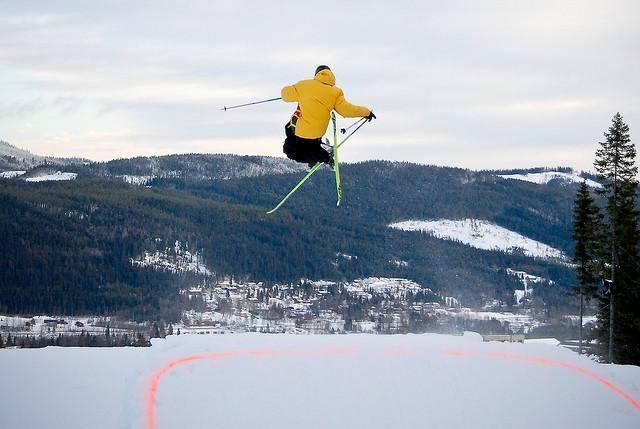How many cows are laying down in this image?
Give a very brief answer. 0. 